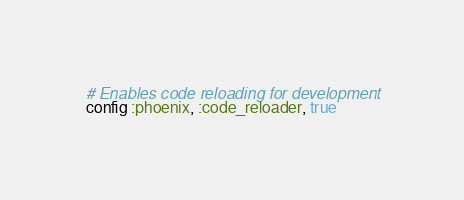Convert code to text. <code><loc_0><loc_0><loc_500><loc_500><_Elixir_># Enables code reloading for development
config :phoenix, :code_reloader, true
</code> 